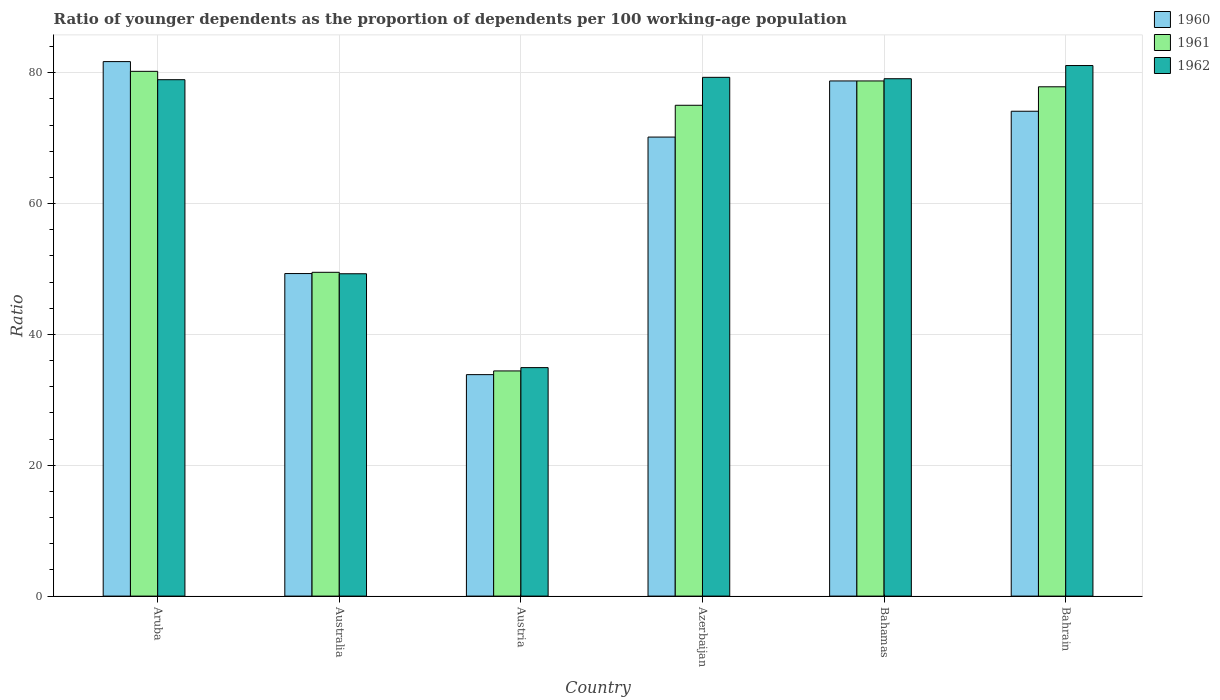How many different coloured bars are there?
Offer a terse response. 3. How many groups of bars are there?
Provide a succinct answer. 6. Are the number of bars per tick equal to the number of legend labels?
Provide a succinct answer. Yes. Are the number of bars on each tick of the X-axis equal?
Make the answer very short. Yes. What is the label of the 3rd group of bars from the left?
Offer a very short reply. Austria. In how many cases, is the number of bars for a given country not equal to the number of legend labels?
Keep it short and to the point. 0. What is the age dependency ratio(young) in 1961 in Aruba?
Make the answer very short. 80.21. Across all countries, what is the maximum age dependency ratio(young) in 1961?
Keep it short and to the point. 80.21. Across all countries, what is the minimum age dependency ratio(young) in 1962?
Ensure brevity in your answer.  34.93. In which country was the age dependency ratio(young) in 1960 maximum?
Provide a short and direct response. Aruba. In which country was the age dependency ratio(young) in 1960 minimum?
Provide a short and direct response. Austria. What is the total age dependency ratio(young) in 1962 in the graph?
Your response must be concise. 402.62. What is the difference between the age dependency ratio(young) in 1961 in Azerbaijan and that in Bahamas?
Your response must be concise. -3.72. What is the difference between the age dependency ratio(young) in 1961 in Bahamas and the age dependency ratio(young) in 1960 in Australia?
Give a very brief answer. 29.44. What is the average age dependency ratio(young) in 1962 per country?
Ensure brevity in your answer.  67.1. What is the difference between the age dependency ratio(young) of/in 1960 and age dependency ratio(young) of/in 1962 in Australia?
Offer a terse response. 0.03. In how many countries, is the age dependency ratio(young) in 1961 greater than 52?
Make the answer very short. 4. What is the ratio of the age dependency ratio(young) in 1960 in Australia to that in Azerbaijan?
Keep it short and to the point. 0.7. Is the age dependency ratio(young) in 1962 in Aruba less than that in Bahamas?
Offer a very short reply. Yes. Is the difference between the age dependency ratio(young) in 1960 in Australia and Austria greater than the difference between the age dependency ratio(young) in 1962 in Australia and Austria?
Your response must be concise. Yes. What is the difference between the highest and the second highest age dependency ratio(young) in 1961?
Ensure brevity in your answer.  2.36. What is the difference between the highest and the lowest age dependency ratio(young) in 1960?
Provide a succinct answer. 47.85. Is the sum of the age dependency ratio(young) in 1960 in Australia and Austria greater than the maximum age dependency ratio(young) in 1961 across all countries?
Keep it short and to the point. Yes. What does the 2nd bar from the right in Bahrain represents?
Your answer should be compact. 1961. What is the difference between two consecutive major ticks on the Y-axis?
Your response must be concise. 20. Does the graph contain grids?
Your answer should be very brief. Yes. How many legend labels are there?
Make the answer very short. 3. How are the legend labels stacked?
Your answer should be compact. Vertical. What is the title of the graph?
Provide a short and direct response. Ratio of younger dependents as the proportion of dependents per 100 working-age population. What is the label or title of the X-axis?
Keep it short and to the point. Country. What is the label or title of the Y-axis?
Your answer should be compact. Ratio. What is the Ratio of 1960 in Aruba?
Your answer should be very brief. 81.7. What is the Ratio in 1961 in Aruba?
Keep it short and to the point. 80.21. What is the Ratio of 1962 in Aruba?
Provide a succinct answer. 78.94. What is the Ratio in 1960 in Australia?
Give a very brief answer. 49.3. What is the Ratio of 1961 in Australia?
Your answer should be very brief. 49.49. What is the Ratio of 1962 in Australia?
Offer a very short reply. 49.27. What is the Ratio in 1960 in Austria?
Your answer should be very brief. 33.85. What is the Ratio of 1961 in Austria?
Provide a short and direct response. 34.42. What is the Ratio of 1962 in Austria?
Ensure brevity in your answer.  34.93. What is the Ratio of 1960 in Azerbaijan?
Make the answer very short. 70.17. What is the Ratio of 1961 in Azerbaijan?
Give a very brief answer. 75.03. What is the Ratio in 1962 in Azerbaijan?
Give a very brief answer. 79.3. What is the Ratio in 1960 in Bahamas?
Your answer should be compact. 78.75. What is the Ratio in 1961 in Bahamas?
Keep it short and to the point. 78.75. What is the Ratio in 1962 in Bahamas?
Offer a very short reply. 79.08. What is the Ratio in 1960 in Bahrain?
Offer a terse response. 74.12. What is the Ratio of 1961 in Bahrain?
Offer a terse response. 77.85. What is the Ratio of 1962 in Bahrain?
Give a very brief answer. 81.1. Across all countries, what is the maximum Ratio in 1960?
Provide a succinct answer. 81.7. Across all countries, what is the maximum Ratio in 1961?
Your response must be concise. 80.21. Across all countries, what is the maximum Ratio in 1962?
Give a very brief answer. 81.1. Across all countries, what is the minimum Ratio in 1960?
Your response must be concise. 33.85. Across all countries, what is the minimum Ratio in 1961?
Provide a succinct answer. 34.42. Across all countries, what is the minimum Ratio of 1962?
Your answer should be very brief. 34.93. What is the total Ratio of 1960 in the graph?
Your response must be concise. 387.89. What is the total Ratio in 1961 in the graph?
Give a very brief answer. 395.75. What is the total Ratio of 1962 in the graph?
Provide a succinct answer. 402.62. What is the difference between the Ratio in 1960 in Aruba and that in Australia?
Offer a very short reply. 32.4. What is the difference between the Ratio of 1961 in Aruba and that in Australia?
Your answer should be compact. 30.72. What is the difference between the Ratio in 1962 in Aruba and that in Australia?
Provide a short and direct response. 29.66. What is the difference between the Ratio in 1960 in Aruba and that in Austria?
Ensure brevity in your answer.  47.85. What is the difference between the Ratio in 1961 in Aruba and that in Austria?
Offer a very short reply. 45.8. What is the difference between the Ratio in 1962 in Aruba and that in Austria?
Keep it short and to the point. 44.01. What is the difference between the Ratio in 1960 in Aruba and that in Azerbaijan?
Provide a short and direct response. 11.54. What is the difference between the Ratio in 1961 in Aruba and that in Azerbaijan?
Offer a terse response. 5.19. What is the difference between the Ratio of 1962 in Aruba and that in Azerbaijan?
Keep it short and to the point. -0.36. What is the difference between the Ratio of 1960 in Aruba and that in Bahamas?
Provide a short and direct response. 2.96. What is the difference between the Ratio in 1961 in Aruba and that in Bahamas?
Keep it short and to the point. 1.47. What is the difference between the Ratio of 1962 in Aruba and that in Bahamas?
Ensure brevity in your answer.  -0.15. What is the difference between the Ratio in 1960 in Aruba and that in Bahrain?
Provide a succinct answer. 7.59. What is the difference between the Ratio of 1961 in Aruba and that in Bahrain?
Your answer should be compact. 2.36. What is the difference between the Ratio in 1962 in Aruba and that in Bahrain?
Your answer should be very brief. -2.16. What is the difference between the Ratio of 1960 in Australia and that in Austria?
Provide a succinct answer. 15.45. What is the difference between the Ratio of 1961 in Australia and that in Austria?
Your answer should be compact. 15.08. What is the difference between the Ratio of 1962 in Australia and that in Austria?
Provide a short and direct response. 14.35. What is the difference between the Ratio of 1960 in Australia and that in Azerbaijan?
Make the answer very short. -20.86. What is the difference between the Ratio in 1961 in Australia and that in Azerbaijan?
Your response must be concise. -25.53. What is the difference between the Ratio of 1962 in Australia and that in Azerbaijan?
Offer a terse response. -30.02. What is the difference between the Ratio of 1960 in Australia and that in Bahamas?
Offer a terse response. -29.44. What is the difference between the Ratio of 1961 in Australia and that in Bahamas?
Make the answer very short. -29.25. What is the difference between the Ratio in 1962 in Australia and that in Bahamas?
Offer a terse response. -29.81. What is the difference between the Ratio in 1960 in Australia and that in Bahrain?
Keep it short and to the point. -24.81. What is the difference between the Ratio of 1961 in Australia and that in Bahrain?
Your response must be concise. -28.36. What is the difference between the Ratio in 1962 in Australia and that in Bahrain?
Offer a terse response. -31.83. What is the difference between the Ratio of 1960 in Austria and that in Azerbaijan?
Provide a succinct answer. -36.31. What is the difference between the Ratio of 1961 in Austria and that in Azerbaijan?
Your answer should be very brief. -40.61. What is the difference between the Ratio in 1962 in Austria and that in Azerbaijan?
Keep it short and to the point. -44.37. What is the difference between the Ratio in 1960 in Austria and that in Bahamas?
Provide a short and direct response. -44.89. What is the difference between the Ratio in 1961 in Austria and that in Bahamas?
Keep it short and to the point. -44.33. What is the difference between the Ratio in 1962 in Austria and that in Bahamas?
Provide a short and direct response. -44.16. What is the difference between the Ratio in 1960 in Austria and that in Bahrain?
Offer a terse response. -40.26. What is the difference between the Ratio of 1961 in Austria and that in Bahrain?
Your response must be concise. -43.43. What is the difference between the Ratio in 1962 in Austria and that in Bahrain?
Ensure brevity in your answer.  -46.17. What is the difference between the Ratio of 1960 in Azerbaijan and that in Bahamas?
Provide a short and direct response. -8.58. What is the difference between the Ratio in 1961 in Azerbaijan and that in Bahamas?
Your answer should be very brief. -3.72. What is the difference between the Ratio in 1962 in Azerbaijan and that in Bahamas?
Provide a short and direct response. 0.21. What is the difference between the Ratio in 1960 in Azerbaijan and that in Bahrain?
Offer a very short reply. -3.95. What is the difference between the Ratio of 1961 in Azerbaijan and that in Bahrain?
Your answer should be very brief. -2.83. What is the difference between the Ratio of 1962 in Azerbaijan and that in Bahrain?
Keep it short and to the point. -1.8. What is the difference between the Ratio of 1960 in Bahamas and that in Bahrain?
Ensure brevity in your answer.  4.63. What is the difference between the Ratio of 1961 in Bahamas and that in Bahrain?
Ensure brevity in your answer.  0.89. What is the difference between the Ratio in 1962 in Bahamas and that in Bahrain?
Provide a succinct answer. -2.02. What is the difference between the Ratio in 1960 in Aruba and the Ratio in 1961 in Australia?
Your response must be concise. 32.21. What is the difference between the Ratio in 1960 in Aruba and the Ratio in 1962 in Australia?
Offer a very short reply. 32.43. What is the difference between the Ratio in 1961 in Aruba and the Ratio in 1962 in Australia?
Your response must be concise. 30.94. What is the difference between the Ratio of 1960 in Aruba and the Ratio of 1961 in Austria?
Provide a succinct answer. 47.28. What is the difference between the Ratio in 1960 in Aruba and the Ratio in 1962 in Austria?
Offer a terse response. 46.78. What is the difference between the Ratio of 1961 in Aruba and the Ratio of 1962 in Austria?
Offer a very short reply. 45.29. What is the difference between the Ratio of 1960 in Aruba and the Ratio of 1961 in Azerbaijan?
Make the answer very short. 6.67. What is the difference between the Ratio of 1960 in Aruba and the Ratio of 1962 in Azerbaijan?
Keep it short and to the point. 2.41. What is the difference between the Ratio in 1961 in Aruba and the Ratio in 1962 in Azerbaijan?
Your answer should be compact. 0.92. What is the difference between the Ratio in 1960 in Aruba and the Ratio in 1961 in Bahamas?
Provide a short and direct response. 2.96. What is the difference between the Ratio of 1960 in Aruba and the Ratio of 1962 in Bahamas?
Offer a terse response. 2.62. What is the difference between the Ratio in 1961 in Aruba and the Ratio in 1962 in Bahamas?
Keep it short and to the point. 1.13. What is the difference between the Ratio of 1960 in Aruba and the Ratio of 1961 in Bahrain?
Give a very brief answer. 3.85. What is the difference between the Ratio of 1960 in Aruba and the Ratio of 1962 in Bahrain?
Make the answer very short. 0.6. What is the difference between the Ratio in 1961 in Aruba and the Ratio in 1962 in Bahrain?
Offer a terse response. -0.89. What is the difference between the Ratio in 1960 in Australia and the Ratio in 1961 in Austria?
Ensure brevity in your answer.  14.89. What is the difference between the Ratio of 1960 in Australia and the Ratio of 1962 in Austria?
Your answer should be very brief. 14.38. What is the difference between the Ratio of 1961 in Australia and the Ratio of 1962 in Austria?
Give a very brief answer. 14.57. What is the difference between the Ratio of 1960 in Australia and the Ratio of 1961 in Azerbaijan?
Make the answer very short. -25.72. What is the difference between the Ratio in 1960 in Australia and the Ratio in 1962 in Azerbaijan?
Offer a terse response. -29.99. What is the difference between the Ratio of 1961 in Australia and the Ratio of 1962 in Azerbaijan?
Provide a short and direct response. -29.8. What is the difference between the Ratio in 1960 in Australia and the Ratio in 1961 in Bahamas?
Offer a terse response. -29.44. What is the difference between the Ratio in 1960 in Australia and the Ratio in 1962 in Bahamas?
Keep it short and to the point. -29.78. What is the difference between the Ratio in 1961 in Australia and the Ratio in 1962 in Bahamas?
Offer a very short reply. -29.59. What is the difference between the Ratio in 1960 in Australia and the Ratio in 1961 in Bahrain?
Keep it short and to the point. -28.55. What is the difference between the Ratio of 1960 in Australia and the Ratio of 1962 in Bahrain?
Offer a terse response. -31.8. What is the difference between the Ratio of 1961 in Australia and the Ratio of 1962 in Bahrain?
Offer a very short reply. -31.61. What is the difference between the Ratio of 1960 in Austria and the Ratio of 1961 in Azerbaijan?
Make the answer very short. -41.17. What is the difference between the Ratio in 1960 in Austria and the Ratio in 1962 in Azerbaijan?
Provide a succinct answer. -45.44. What is the difference between the Ratio of 1961 in Austria and the Ratio of 1962 in Azerbaijan?
Ensure brevity in your answer.  -44.88. What is the difference between the Ratio in 1960 in Austria and the Ratio in 1961 in Bahamas?
Offer a very short reply. -44.89. What is the difference between the Ratio of 1960 in Austria and the Ratio of 1962 in Bahamas?
Provide a succinct answer. -45.23. What is the difference between the Ratio of 1961 in Austria and the Ratio of 1962 in Bahamas?
Provide a succinct answer. -44.67. What is the difference between the Ratio in 1960 in Austria and the Ratio in 1961 in Bahrain?
Make the answer very short. -44. What is the difference between the Ratio of 1960 in Austria and the Ratio of 1962 in Bahrain?
Your answer should be very brief. -47.25. What is the difference between the Ratio in 1961 in Austria and the Ratio in 1962 in Bahrain?
Provide a succinct answer. -46.68. What is the difference between the Ratio of 1960 in Azerbaijan and the Ratio of 1961 in Bahamas?
Offer a very short reply. -8.58. What is the difference between the Ratio in 1960 in Azerbaijan and the Ratio in 1962 in Bahamas?
Offer a very short reply. -8.92. What is the difference between the Ratio in 1961 in Azerbaijan and the Ratio in 1962 in Bahamas?
Make the answer very short. -4.06. What is the difference between the Ratio in 1960 in Azerbaijan and the Ratio in 1961 in Bahrain?
Make the answer very short. -7.69. What is the difference between the Ratio in 1960 in Azerbaijan and the Ratio in 1962 in Bahrain?
Keep it short and to the point. -10.93. What is the difference between the Ratio of 1961 in Azerbaijan and the Ratio of 1962 in Bahrain?
Provide a short and direct response. -6.07. What is the difference between the Ratio in 1960 in Bahamas and the Ratio in 1961 in Bahrain?
Your answer should be very brief. 0.89. What is the difference between the Ratio of 1960 in Bahamas and the Ratio of 1962 in Bahrain?
Your response must be concise. -2.35. What is the difference between the Ratio of 1961 in Bahamas and the Ratio of 1962 in Bahrain?
Your response must be concise. -2.35. What is the average Ratio in 1960 per country?
Your answer should be compact. 64.65. What is the average Ratio in 1961 per country?
Make the answer very short. 65.96. What is the average Ratio of 1962 per country?
Keep it short and to the point. 67.1. What is the difference between the Ratio in 1960 and Ratio in 1961 in Aruba?
Your answer should be compact. 1.49. What is the difference between the Ratio in 1960 and Ratio in 1962 in Aruba?
Provide a short and direct response. 2.77. What is the difference between the Ratio of 1961 and Ratio of 1962 in Aruba?
Your answer should be compact. 1.28. What is the difference between the Ratio in 1960 and Ratio in 1961 in Australia?
Offer a terse response. -0.19. What is the difference between the Ratio of 1960 and Ratio of 1962 in Australia?
Offer a terse response. 0.03. What is the difference between the Ratio of 1961 and Ratio of 1962 in Australia?
Give a very brief answer. 0.22. What is the difference between the Ratio of 1960 and Ratio of 1961 in Austria?
Offer a very short reply. -0.57. What is the difference between the Ratio of 1960 and Ratio of 1962 in Austria?
Offer a terse response. -1.07. What is the difference between the Ratio of 1961 and Ratio of 1962 in Austria?
Offer a very short reply. -0.51. What is the difference between the Ratio in 1960 and Ratio in 1961 in Azerbaijan?
Make the answer very short. -4.86. What is the difference between the Ratio of 1960 and Ratio of 1962 in Azerbaijan?
Keep it short and to the point. -9.13. What is the difference between the Ratio in 1961 and Ratio in 1962 in Azerbaijan?
Keep it short and to the point. -4.27. What is the difference between the Ratio of 1960 and Ratio of 1961 in Bahamas?
Your response must be concise. 0. What is the difference between the Ratio in 1960 and Ratio in 1962 in Bahamas?
Provide a succinct answer. -0.34. What is the difference between the Ratio in 1961 and Ratio in 1962 in Bahamas?
Keep it short and to the point. -0.34. What is the difference between the Ratio in 1960 and Ratio in 1961 in Bahrain?
Keep it short and to the point. -3.74. What is the difference between the Ratio of 1960 and Ratio of 1962 in Bahrain?
Your answer should be compact. -6.98. What is the difference between the Ratio of 1961 and Ratio of 1962 in Bahrain?
Give a very brief answer. -3.25. What is the ratio of the Ratio of 1960 in Aruba to that in Australia?
Offer a very short reply. 1.66. What is the ratio of the Ratio in 1961 in Aruba to that in Australia?
Give a very brief answer. 1.62. What is the ratio of the Ratio of 1962 in Aruba to that in Australia?
Ensure brevity in your answer.  1.6. What is the ratio of the Ratio of 1960 in Aruba to that in Austria?
Provide a succinct answer. 2.41. What is the ratio of the Ratio of 1961 in Aruba to that in Austria?
Offer a terse response. 2.33. What is the ratio of the Ratio of 1962 in Aruba to that in Austria?
Keep it short and to the point. 2.26. What is the ratio of the Ratio of 1960 in Aruba to that in Azerbaijan?
Ensure brevity in your answer.  1.16. What is the ratio of the Ratio in 1961 in Aruba to that in Azerbaijan?
Your response must be concise. 1.07. What is the ratio of the Ratio in 1960 in Aruba to that in Bahamas?
Offer a terse response. 1.04. What is the ratio of the Ratio in 1961 in Aruba to that in Bahamas?
Give a very brief answer. 1.02. What is the ratio of the Ratio of 1962 in Aruba to that in Bahamas?
Offer a terse response. 1. What is the ratio of the Ratio in 1960 in Aruba to that in Bahrain?
Give a very brief answer. 1.1. What is the ratio of the Ratio of 1961 in Aruba to that in Bahrain?
Provide a short and direct response. 1.03. What is the ratio of the Ratio of 1962 in Aruba to that in Bahrain?
Your answer should be compact. 0.97. What is the ratio of the Ratio of 1960 in Australia to that in Austria?
Offer a terse response. 1.46. What is the ratio of the Ratio of 1961 in Australia to that in Austria?
Provide a succinct answer. 1.44. What is the ratio of the Ratio of 1962 in Australia to that in Austria?
Give a very brief answer. 1.41. What is the ratio of the Ratio of 1960 in Australia to that in Azerbaijan?
Keep it short and to the point. 0.7. What is the ratio of the Ratio of 1961 in Australia to that in Azerbaijan?
Ensure brevity in your answer.  0.66. What is the ratio of the Ratio in 1962 in Australia to that in Azerbaijan?
Provide a succinct answer. 0.62. What is the ratio of the Ratio of 1960 in Australia to that in Bahamas?
Your answer should be very brief. 0.63. What is the ratio of the Ratio of 1961 in Australia to that in Bahamas?
Provide a succinct answer. 0.63. What is the ratio of the Ratio in 1962 in Australia to that in Bahamas?
Offer a terse response. 0.62. What is the ratio of the Ratio in 1960 in Australia to that in Bahrain?
Your answer should be compact. 0.67. What is the ratio of the Ratio of 1961 in Australia to that in Bahrain?
Give a very brief answer. 0.64. What is the ratio of the Ratio in 1962 in Australia to that in Bahrain?
Provide a succinct answer. 0.61. What is the ratio of the Ratio in 1960 in Austria to that in Azerbaijan?
Ensure brevity in your answer.  0.48. What is the ratio of the Ratio of 1961 in Austria to that in Azerbaijan?
Keep it short and to the point. 0.46. What is the ratio of the Ratio of 1962 in Austria to that in Azerbaijan?
Provide a short and direct response. 0.44. What is the ratio of the Ratio in 1960 in Austria to that in Bahamas?
Keep it short and to the point. 0.43. What is the ratio of the Ratio in 1961 in Austria to that in Bahamas?
Your answer should be very brief. 0.44. What is the ratio of the Ratio of 1962 in Austria to that in Bahamas?
Ensure brevity in your answer.  0.44. What is the ratio of the Ratio of 1960 in Austria to that in Bahrain?
Your answer should be compact. 0.46. What is the ratio of the Ratio of 1961 in Austria to that in Bahrain?
Provide a succinct answer. 0.44. What is the ratio of the Ratio of 1962 in Austria to that in Bahrain?
Your answer should be compact. 0.43. What is the ratio of the Ratio in 1960 in Azerbaijan to that in Bahamas?
Your answer should be compact. 0.89. What is the ratio of the Ratio in 1961 in Azerbaijan to that in Bahamas?
Your response must be concise. 0.95. What is the ratio of the Ratio in 1960 in Azerbaijan to that in Bahrain?
Keep it short and to the point. 0.95. What is the ratio of the Ratio in 1961 in Azerbaijan to that in Bahrain?
Provide a succinct answer. 0.96. What is the ratio of the Ratio of 1962 in Azerbaijan to that in Bahrain?
Make the answer very short. 0.98. What is the ratio of the Ratio in 1961 in Bahamas to that in Bahrain?
Your answer should be very brief. 1.01. What is the ratio of the Ratio in 1962 in Bahamas to that in Bahrain?
Your answer should be very brief. 0.98. What is the difference between the highest and the second highest Ratio of 1960?
Offer a very short reply. 2.96. What is the difference between the highest and the second highest Ratio of 1961?
Your answer should be compact. 1.47. What is the difference between the highest and the second highest Ratio in 1962?
Provide a succinct answer. 1.8. What is the difference between the highest and the lowest Ratio in 1960?
Provide a short and direct response. 47.85. What is the difference between the highest and the lowest Ratio of 1961?
Provide a short and direct response. 45.8. What is the difference between the highest and the lowest Ratio in 1962?
Give a very brief answer. 46.17. 